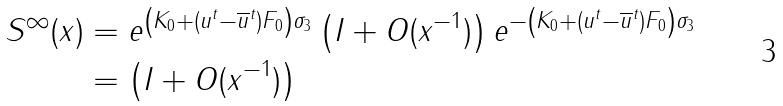<formula> <loc_0><loc_0><loc_500><loc_500>S ^ { \infty } ( x ) & = e ^ { \left ( K _ { 0 } + ( u ^ { t } - \overline { u } ^ { t } ) F _ { 0 } \right ) \sigma _ { 3 } } \left ( I + O ( x ^ { - 1 } ) \right ) e ^ { - \left ( K _ { 0 } + ( u ^ { t } - \overline { u } ^ { t } ) F _ { 0 } \right ) \sigma _ { 3 } } \\ & = \left ( I + O ( x ^ { - 1 } ) \right )</formula> 